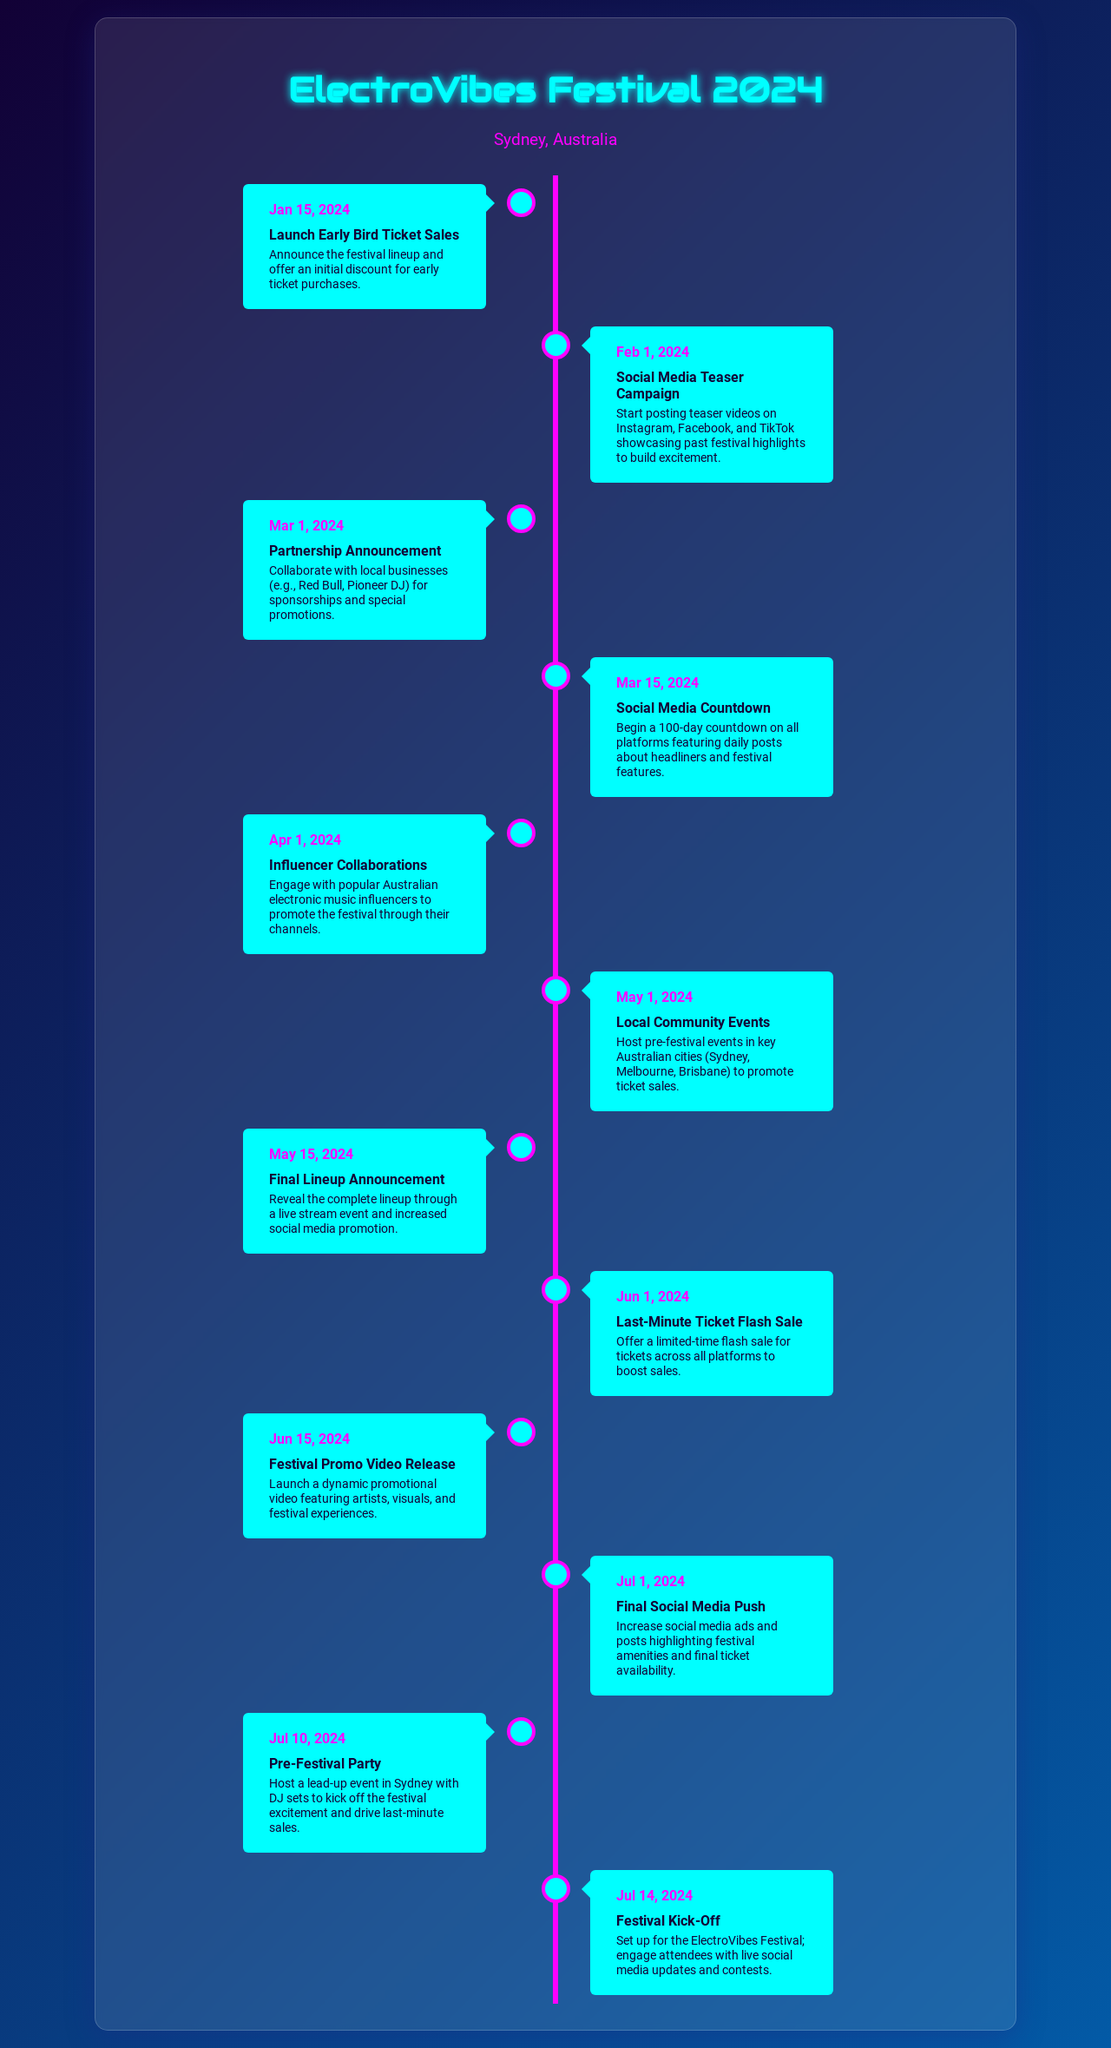What is the date for the Early Bird Ticket Sales launch? The Early Bird Ticket Sales are scheduled for January 15, 2024, as mentioned in the timeline.
Answer: January 15, 2024 What activity starts on February 1, 2024? The activity scheduled for February 1, 2024, is the Social Media Teaser Campaign, which aims to build excitement.
Answer: Social Media Teaser Campaign When will the Final Lineup be announced? The Final Lineup Announcement is set for May 15, 2024, according to the marketing timeline provided.
Answer: May 15, 2024 How many days of countdown will start on March 15, 2024? The Social Media Countdown beginning on March 15, 2024, will feature a 100-day countdown to the festival.
Answer: 100 days What is the last promotional event before the festival? The last promotional event before the festival is the Festival Kick-Off on July 14, 2024.
Answer: Festival Kick-Off Which activity involves collaborating with influencers? The Influencer Collaborations scheduled for April 1, 2024, involves engaging popular Australian electronic music influencers.
Answer: Influencer Collaborations On what date is the Last-Minute Ticket Flash Sale? The Last-Minute Ticket Flash Sale is scheduled for June 1, 2024, according to the timeline.
Answer: June 1, 2024 What promotional activity is scheduled for July 1, 2024? The Final Social Media Push is the promotional activity scheduled for July 1, 2024, to boost visibility.
Answer: Final Social Media Push What are the locations for community events in May 2024? The local community events are set to take place in Sydney, Melbourne, and Brisbane to promote ticket sales.
Answer: Sydney, Melbourne, Brisbane 